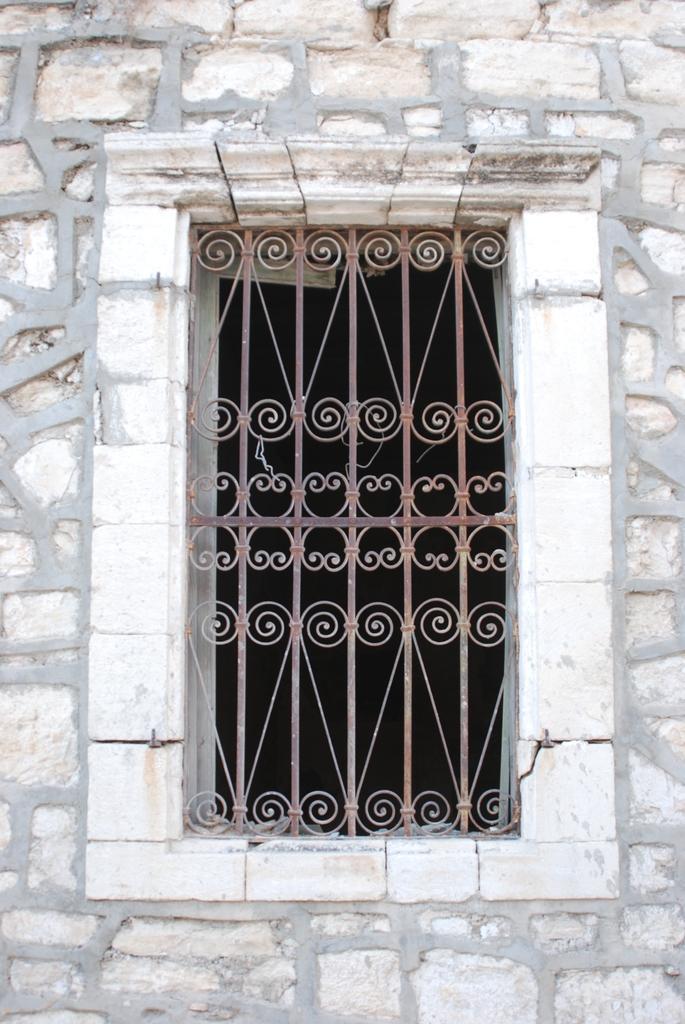How would you summarize this image in a sentence or two? Here in this picture we can see a window present on the wall over there. 